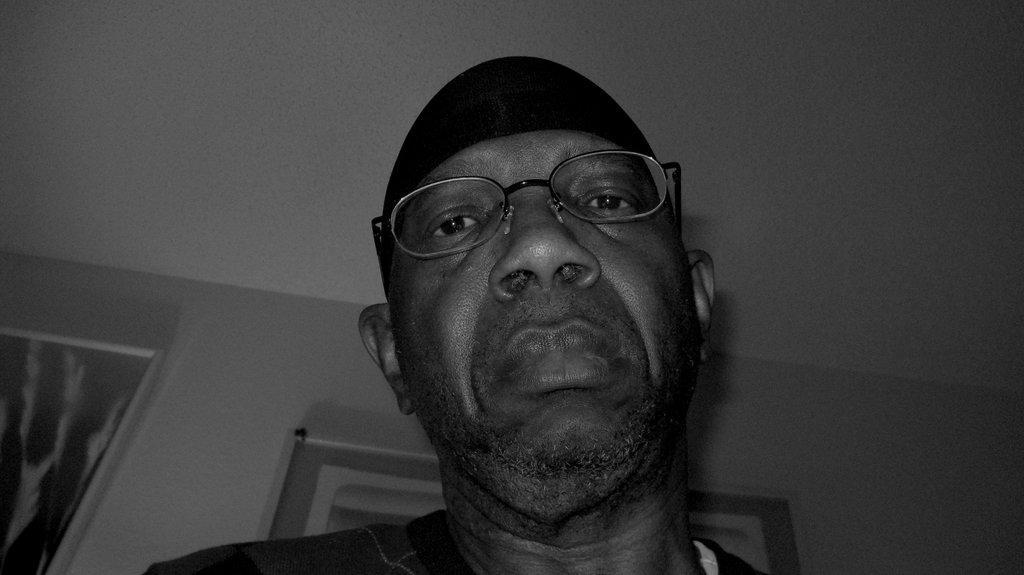Could you give a brief overview of what you see in this image? In this picture we can see a person wearing a spectacle on his eyes and a cap on his head. There are a few frames visible on the wall. 